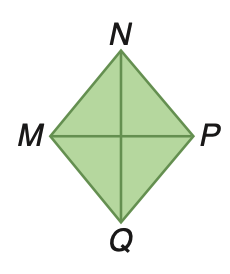Answer the mathemtical geometry problem and directly provide the correct option letter.
Question: Rhombus M N P Q has an area of 375 square inches. If M P is 25 inches, find N Q.
Choices: A: 15 B: 25 C: 30 D: 50 C 